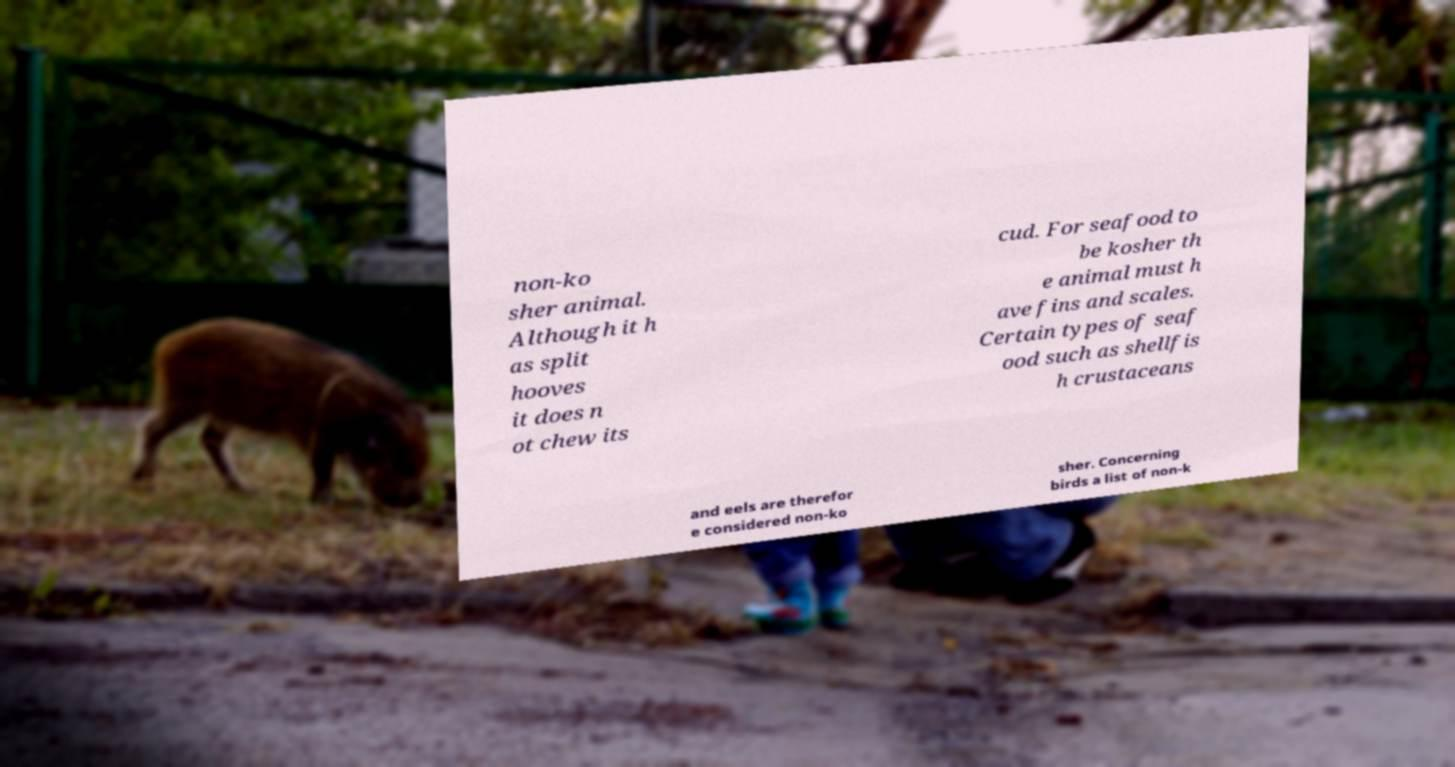I need the written content from this picture converted into text. Can you do that? non-ko sher animal. Although it h as split hooves it does n ot chew its cud. For seafood to be kosher th e animal must h ave fins and scales. Certain types of seaf ood such as shellfis h crustaceans and eels are therefor e considered non-ko sher. Concerning birds a list of non-k 